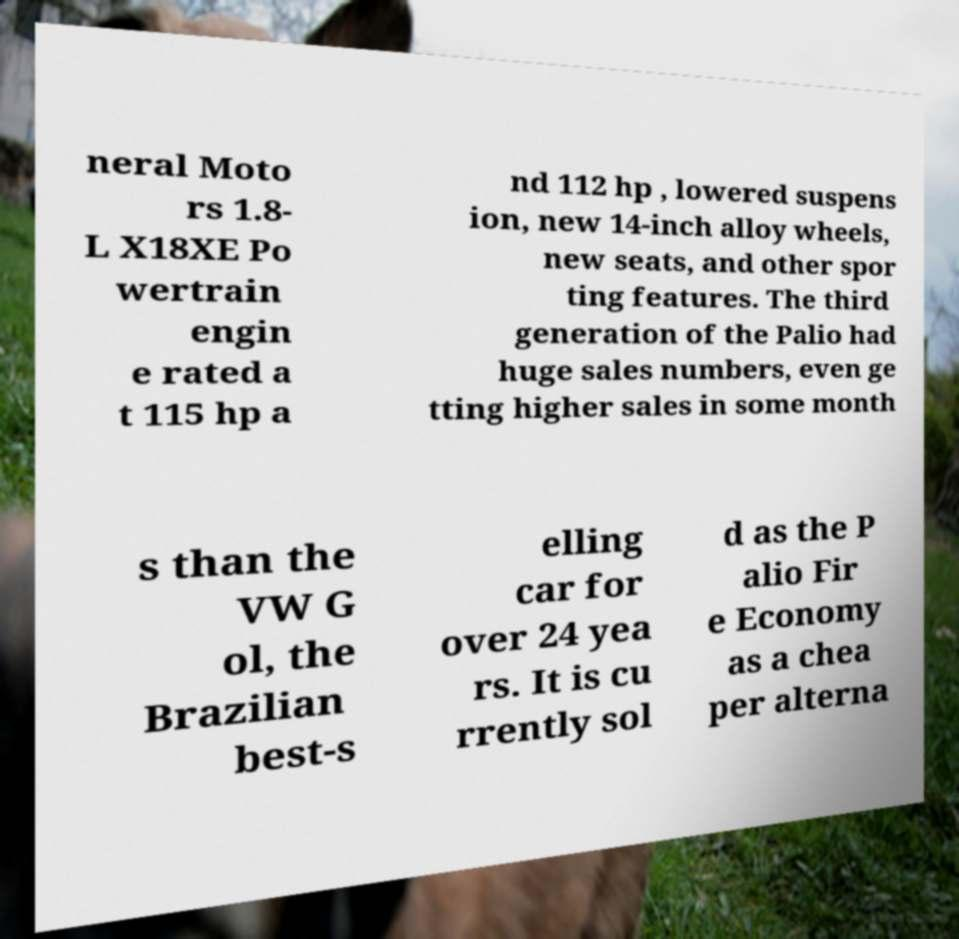For documentation purposes, I need the text within this image transcribed. Could you provide that? neral Moto rs 1.8- L X18XE Po wertrain engin e rated a t 115 hp a nd 112 hp , lowered suspens ion, new 14-inch alloy wheels, new seats, and other spor ting features. The third generation of the Palio had huge sales numbers, even ge tting higher sales in some month s than the VW G ol, the Brazilian best-s elling car for over 24 yea rs. It is cu rrently sol d as the P alio Fir e Economy as a chea per alterna 